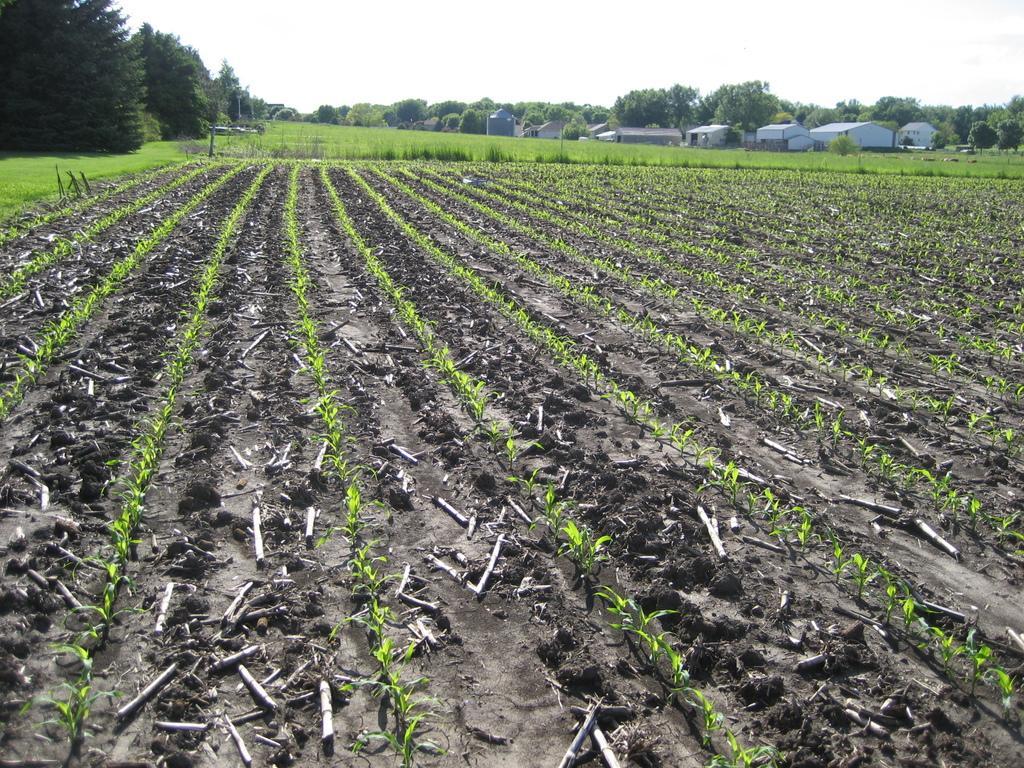Could you give a brief overview of what you see in this image? In this image there is the sky, there are trees, there are houses, there are grass, there are plants planted in the soil. 